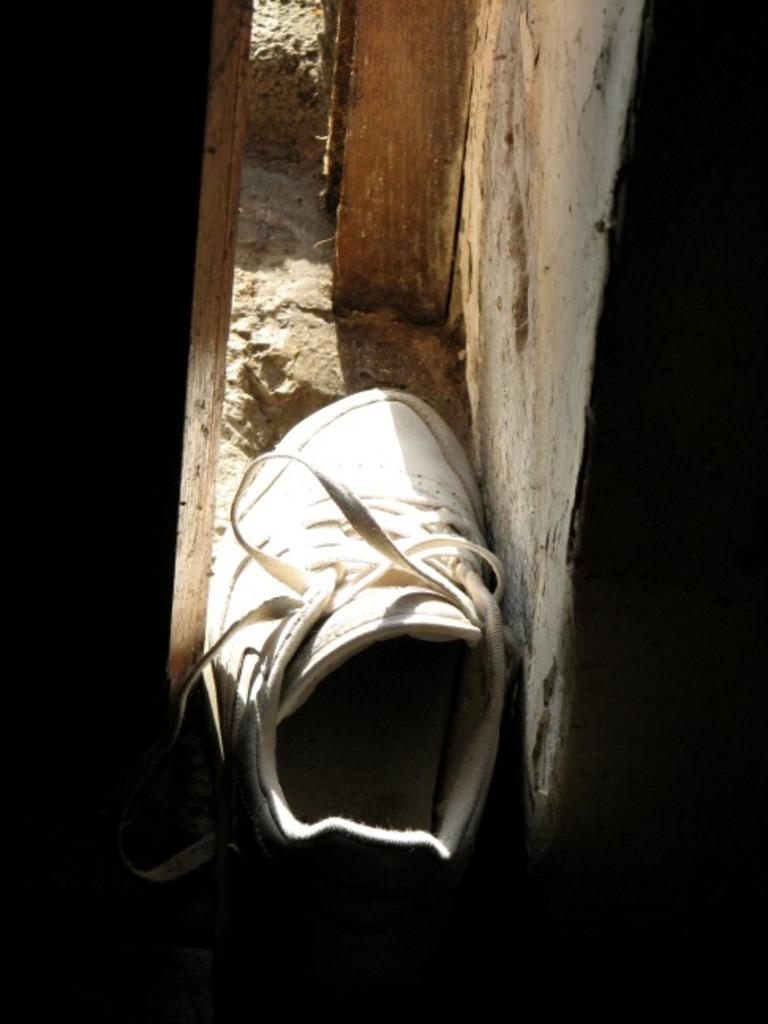What type of footwear is visible in the image? There is a white color shoe in the image. What is the background of the image? There is a wall in the image. What material is used for the object in the image? There is a wooden object in the image. What type of country is depicted in the image? There is no country depicted in the image; it only features a white color shoe, a wall, and a wooden object. 